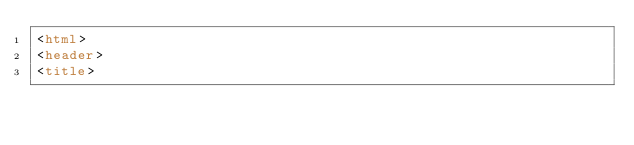Convert code to text. <code><loc_0><loc_0><loc_500><loc_500><_HTML_><html>
<header>
<title></code> 